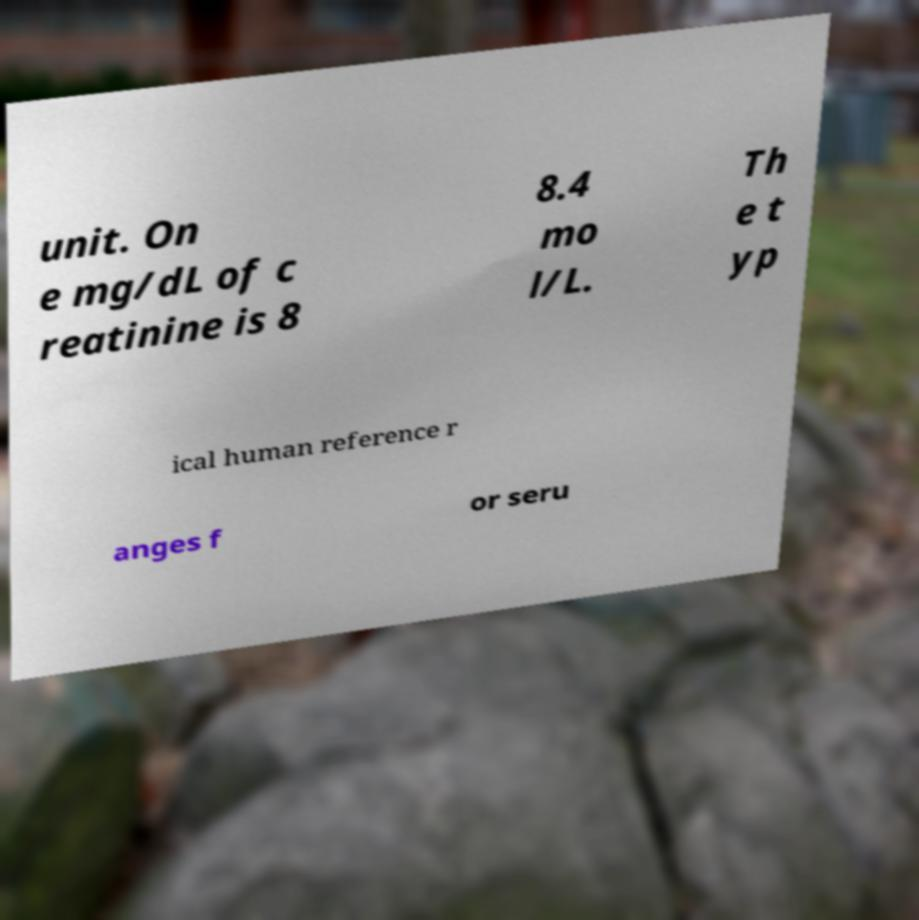Could you extract and type out the text from this image? unit. On e mg/dL of c reatinine is 8 8.4 mo l/L. Th e t yp ical human reference r anges f or seru 